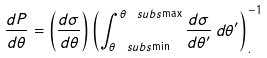<formula> <loc_0><loc_0><loc_500><loc_500>\frac { d P } { d \theta } = \left ( \frac { d \sigma } { d \theta } \right ) \left ( \int _ { \theta _ { \ } s u b s { \min } } ^ { \theta _ { \ } s u b s { \max } } \frac { d \sigma } { d \theta ^ { \prime } } \, d \theta ^ { \prime } \right ) ^ { - 1 } _ { . }</formula> 